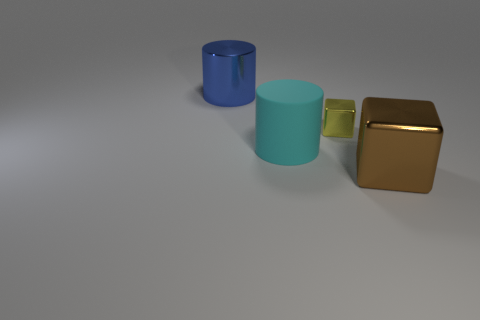What can you infer about the material of the objects based on their appearance? The blue and turquoise objects exhibit a glossy, reflective surface, suggesting they could be made of some type of smooth plastic or coated material. The brown object appears to have a metallic finish and thus could be composed of metal or a metal-like substance. 